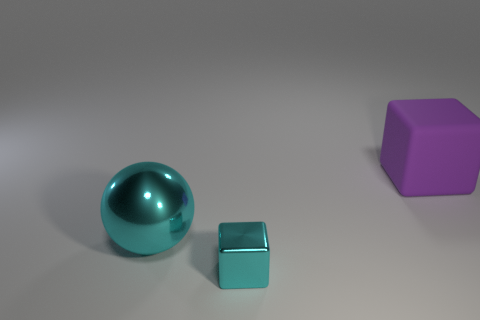Add 3 purple matte cubes. How many objects exist? 6 Subtract all spheres. How many objects are left? 2 Subtract all metal things. Subtract all big cyan balls. How many objects are left? 0 Add 1 big matte things. How many big matte things are left? 2 Add 1 tiny cyan objects. How many tiny cyan objects exist? 2 Subtract 0 gray blocks. How many objects are left? 3 